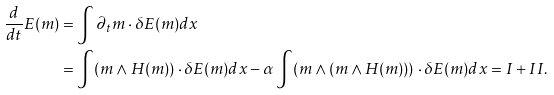<formula> <loc_0><loc_0><loc_500><loc_500>\frac { d } { d t } E ( m ) & = \int \partial _ { t } m \cdot \delta E ( m ) d x \\ & = \int ( m \wedge H ( m ) ) \cdot \delta E ( m ) d x - \alpha \int ( m \wedge ( m \wedge H ( m ) ) ) \cdot \delta E ( m ) d x = I + I I .</formula> 